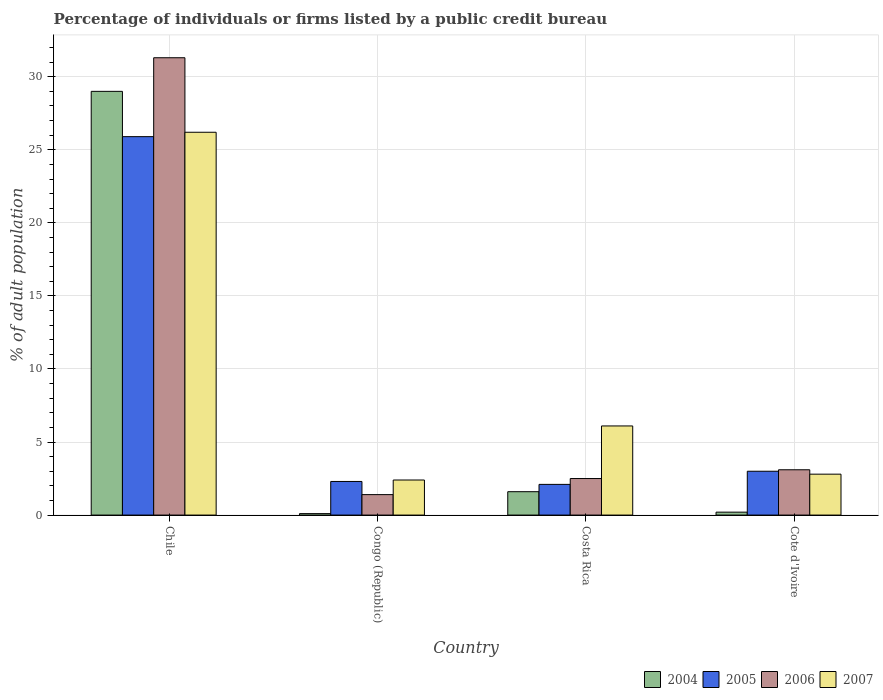How many groups of bars are there?
Make the answer very short. 4. Are the number of bars on each tick of the X-axis equal?
Ensure brevity in your answer.  Yes. How many bars are there on the 4th tick from the left?
Offer a terse response. 4. How many bars are there on the 1st tick from the right?
Your answer should be compact. 4. What is the label of the 4th group of bars from the left?
Give a very brief answer. Cote d'Ivoire. What is the percentage of population listed by a public credit bureau in 2005 in Chile?
Make the answer very short. 25.9. Across all countries, what is the maximum percentage of population listed by a public credit bureau in 2007?
Ensure brevity in your answer.  26.2. Across all countries, what is the minimum percentage of population listed by a public credit bureau in 2007?
Keep it short and to the point. 2.4. In which country was the percentage of population listed by a public credit bureau in 2006 maximum?
Provide a succinct answer. Chile. What is the total percentage of population listed by a public credit bureau in 2004 in the graph?
Ensure brevity in your answer.  30.9. What is the difference between the percentage of population listed by a public credit bureau in 2005 in Chile and that in Congo (Republic)?
Give a very brief answer. 23.6. What is the difference between the percentage of population listed by a public credit bureau in 2005 in Chile and the percentage of population listed by a public credit bureau in 2007 in Costa Rica?
Make the answer very short. 19.8. What is the average percentage of population listed by a public credit bureau in 2007 per country?
Your answer should be very brief. 9.37. What is the difference between the percentage of population listed by a public credit bureau of/in 2006 and percentage of population listed by a public credit bureau of/in 2004 in Costa Rica?
Make the answer very short. 0.9. In how many countries, is the percentage of population listed by a public credit bureau in 2007 greater than 31 %?
Give a very brief answer. 0. What is the ratio of the percentage of population listed by a public credit bureau in 2007 in Chile to that in Cote d'Ivoire?
Give a very brief answer. 9.36. Is the percentage of population listed by a public credit bureau in 2006 in Costa Rica less than that in Cote d'Ivoire?
Provide a short and direct response. Yes. What is the difference between the highest and the second highest percentage of population listed by a public credit bureau in 2007?
Offer a very short reply. 23.4. What is the difference between the highest and the lowest percentage of population listed by a public credit bureau in 2007?
Provide a short and direct response. 23.8. In how many countries, is the percentage of population listed by a public credit bureau in 2006 greater than the average percentage of population listed by a public credit bureau in 2006 taken over all countries?
Provide a succinct answer. 1. Is the sum of the percentage of population listed by a public credit bureau in 2004 in Chile and Cote d'Ivoire greater than the maximum percentage of population listed by a public credit bureau in 2006 across all countries?
Provide a short and direct response. No. Is it the case that in every country, the sum of the percentage of population listed by a public credit bureau in 2004 and percentage of population listed by a public credit bureau in 2005 is greater than the sum of percentage of population listed by a public credit bureau in 2007 and percentage of population listed by a public credit bureau in 2006?
Your answer should be compact. Yes. What does the 4th bar from the left in Costa Rica represents?
Ensure brevity in your answer.  2007. What does the 2nd bar from the right in Cote d'Ivoire represents?
Make the answer very short. 2006. Is it the case that in every country, the sum of the percentage of population listed by a public credit bureau in 2007 and percentage of population listed by a public credit bureau in 2005 is greater than the percentage of population listed by a public credit bureau in 2006?
Your answer should be very brief. Yes. Are all the bars in the graph horizontal?
Keep it short and to the point. No. Are the values on the major ticks of Y-axis written in scientific E-notation?
Provide a short and direct response. No. Does the graph contain grids?
Ensure brevity in your answer.  Yes. What is the title of the graph?
Make the answer very short. Percentage of individuals or firms listed by a public credit bureau. What is the label or title of the X-axis?
Offer a terse response. Country. What is the label or title of the Y-axis?
Ensure brevity in your answer.  % of adult population. What is the % of adult population of 2004 in Chile?
Your answer should be very brief. 29. What is the % of adult population in 2005 in Chile?
Make the answer very short. 25.9. What is the % of adult population in 2006 in Chile?
Your answer should be very brief. 31.3. What is the % of adult population in 2007 in Chile?
Your answer should be very brief. 26.2. What is the % of adult population in 2006 in Congo (Republic)?
Make the answer very short. 1.4. What is the % of adult population of 2005 in Costa Rica?
Offer a very short reply. 2.1. What is the % of adult population in 2006 in Costa Rica?
Offer a very short reply. 2.5. What is the % of adult population of 2004 in Cote d'Ivoire?
Your answer should be very brief. 0.2. What is the % of adult population of 2005 in Cote d'Ivoire?
Your answer should be compact. 3. Across all countries, what is the maximum % of adult population of 2005?
Ensure brevity in your answer.  25.9. Across all countries, what is the maximum % of adult population of 2006?
Your answer should be very brief. 31.3. Across all countries, what is the maximum % of adult population of 2007?
Your response must be concise. 26.2. Across all countries, what is the minimum % of adult population of 2005?
Offer a very short reply. 2.1. What is the total % of adult population of 2004 in the graph?
Ensure brevity in your answer.  30.9. What is the total % of adult population of 2005 in the graph?
Offer a terse response. 33.3. What is the total % of adult population in 2006 in the graph?
Your answer should be compact. 38.3. What is the total % of adult population of 2007 in the graph?
Your answer should be compact. 37.5. What is the difference between the % of adult population of 2004 in Chile and that in Congo (Republic)?
Keep it short and to the point. 28.9. What is the difference between the % of adult population in 2005 in Chile and that in Congo (Republic)?
Offer a terse response. 23.6. What is the difference between the % of adult population of 2006 in Chile and that in Congo (Republic)?
Make the answer very short. 29.9. What is the difference between the % of adult population in 2007 in Chile and that in Congo (Republic)?
Provide a short and direct response. 23.8. What is the difference between the % of adult population of 2004 in Chile and that in Costa Rica?
Provide a short and direct response. 27.4. What is the difference between the % of adult population of 2005 in Chile and that in Costa Rica?
Keep it short and to the point. 23.8. What is the difference between the % of adult population of 2006 in Chile and that in Costa Rica?
Keep it short and to the point. 28.8. What is the difference between the % of adult population in 2007 in Chile and that in Costa Rica?
Provide a short and direct response. 20.1. What is the difference between the % of adult population of 2004 in Chile and that in Cote d'Ivoire?
Provide a short and direct response. 28.8. What is the difference between the % of adult population in 2005 in Chile and that in Cote d'Ivoire?
Provide a succinct answer. 22.9. What is the difference between the % of adult population of 2006 in Chile and that in Cote d'Ivoire?
Your answer should be compact. 28.2. What is the difference between the % of adult population of 2007 in Chile and that in Cote d'Ivoire?
Provide a short and direct response. 23.4. What is the difference between the % of adult population in 2006 in Congo (Republic) and that in Costa Rica?
Your answer should be very brief. -1.1. What is the difference between the % of adult population in 2006 in Costa Rica and that in Cote d'Ivoire?
Give a very brief answer. -0.6. What is the difference between the % of adult population in 2004 in Chile and the % of adult population in 2005 in Congo (Republic)?
Keep it short and to the point. 26.7. What is the difference between the % of adult population in 2004 in Chile and the % of adult population in 2006 in Congo (Republic)?
Make the answer very short. 27.6. What is the difference between the % of adult population in 2004 in Chile and the % of adult population in 2007 in Congo (Republic)?
Give a very brief answer. 26.6. What is the difference between the % of adult population of 2005 in Chile and the % of adult population of 2007 in Congo (Republic)?
Your answer should be compact. 23.5. What is the difference between the % of adult population of 2006 in Chile and the % of adult population of 2007 in Congo (Republic)?
Provide a succinct answer. 28.9. What is the difference between the % of adult population in 2004 in Chile and the % of adult population in 2005 in Costa Rica?
Provide a short and direct response. 26.9. What is the difference between the % of adult population in 2004 in Chile and the % of adult population in 2007 in Costa Rica?
Provide a succinct answer. 22.9. What is the difference between the % of adult population in 2005 in Chile and the % of adult population in 2006 in Costa Rica?
Provide a succinct answer. 23.4. What is the difference between the % of adult population of 2005 in Chile and the % of adult population of 2007 in Costa Rica?
Your answer should be compact. 19.8. What is the difference between the % of adult population in 2006 in Chile and the % of adult population in 2007 in Costa Rica?
Make the answer very short. 25.2. What is the difference between the % of adult population of 2004 in Chile and the % of adult population of 2005 in Cote d'Ivoire?
Provide a short and direct response. 26. What is the difference between the % of adult population of 2004 in Chile and the % of adult population of 2006 in Cote d'Ivoire?
Provide a succinct answer. 25.9. What is the difference between the % of adult population in 2004 in Chile and the % of adult population in 2007 in Cote d'Ivoire?
Offer a terse response. 26.2. What is the difference between the % of adult population in 2005 in Chile and the % of adult population in 2006 in Cote d'Ivoire?
Give a very brief answer. 22.8. What is the difference between the % of adult population in 2005 in Chile and the % of adult population in 2007 in Cote d'Ivoire?
Offer a terse response. 23.1. What is the difference between the % of adult population in 2006 in Chile and the % of adult population in 2007 in Cote d'Ivoire?
Give a very brief answer. 28.5. What is the difference between the % of adult population in 2004 in Congo (Republic) and the % of adult population in 2007 in Costa Rica?
Offer a very short reply. -6. What is the difference between the % of adult population in 2006 in Congo (Republic) and the % of adult population in 2007 in Costa Rica?
Provide a short and direct response. -4.7. What is the difference between the % of adult population in 2004 in Congo (Republic) and the % of adult population in 2005 in Cote d'Ivoire?
Your answer should be compact. -2.9. What is the difference between the % of adult population in 2004 in Congo (Republic) and the % of adult population in 2006 in Cote d'Ivoire?
Give a very brief answer. -3. What is the difference between the % of adult population of 2004 in Congo (Republic) and the % of adult population of 2007 in Cote d'Ivoire?
Give a very brief answer. -2.7. What is the difference between the % of adult population of 2005 in Congo (Republic) and the % of adult population of 2006 in Cote d'Ivoire?
Ensure brevity in your answer.  -0.8. What is the difference between the % of adult population of 2004 in Costa Rica and the % of adult population of 2005 in Cote d'Ivoire?
Ensure brevity in your answer.  -1.4. What is the difference between the % of adult population of 2004 in Costa Rica and the % of adult population of 2006 in Cote d'Ivoire?
Keep it short and to the point. -1.5. What is the difference between the % of adult population of 2005 in Costa Rica and the % of adult population of 2007 in Cote d'Ivoire?
Ensure brevity in your answer.  -0.7. What is the average % of adult population in 2004 per country?
Give a very brief answer. 7.72. What is the average % of adult population in 2005 per country?
Offer a very short reply. 8.32. What is the average % of adult population in 2006 per country?
Make the answer very short. 9.57. What is the average % of adult population in 2007 per country?
Provide a succinct answer. 9.38. What is the difference between the % of adult population in 2004 and % of adult population in 2006 in Chile?
Give a very brief answer. -2.3. What is the difference between the % of adult population of 2004 and % of adult population of 2007 in Chile?
Make the answer very short. 2.8. What is the difference between the % of adult population of 2004 and % of adult population of 2007 in Congo (Republic)?
Make the answer very short. -2.3. What is the difference between the % of adult population of 2004 and % of adult population of 2005 in Costa Rica?
Keep it short and to the point. -0.5. What is the difference between the % of adult population in 2004 and % of adult population in 2007 in Costa Rica?
Offer a very short reply. -4.5. What is the difference between the % of adult population in 2005 and % of adult population in 2006 in Costa Rica?
Ensure brevity in your answer.  -0.4. What is the difference between the % of adult population of 2004 and % of adult population of 2006 in Cote d'Ivoire?
Provide a succinct answer. -2.9. What is the difference between the % of adult population of 2004 and % of adult population of 2007 in Cote d'Ivoire?
Make the answer very short. -2.6. What is the difference between the % of adult population of 2005 and % of adult population of 2006 in Cote d'Ivoire?
Your answer should be very brief. -0.1. What is the difference between the % of adult population in 2006 and % of adult population in 2007 in Cote d'Ivoire?
Provide a short and direct response. 0.3. What is the ratio of the % of adult population in 2004 in Chile to that in Congo (Republic)?
Make the answer very short. 290. What is the ratio of the % of adult population in 2005 in Chile to that in Congo (Republic)?
Your answer should be compact. 11.26. What is the ratio of the % of adult population of 2006 in Chile to that in Congo (Republic)?
Make the answer very short. 22.36. What is the ratio of the % of adult population in 2007 in Chile to that in Congo (Republic)?
Ensure brevity in your answer.  10.92. What is the ratio of the % of adult population in 2004 in Chile to that in Costa Rica?
Ensure brevity in your answer.  18.12. What is the ratio of the % of adult population in 2005 in Chile to that in Costa Rica?
Give a very brief answer. 12.33. What is the ratio of the % of adult population in 2006 in Chile to that in Costa Rica?
Make the answer very short. 12.52. What is the ratio of the % of adult population in 2007 in Chile to that in Costa Rica?
Keep it short and to the point. 4.3. What is the ratio of the % of adult population in 2004 in Chile to that in Cote d'Ivoire?
Your answer should be compact. 145. What is the ratio of the % of adult population of 2005 in Chile to that in Cote d'Ivoire?
Make the answer very short. 8.63. What is the ratio of the % of adult population in 2006 in Chile to that in Cote d'Ivoire?
Your response must be concise. 10.1. What is the ratio of the % of adult population in 2007 in Chile to that in Cote d'Ivoire?
Offer a terse response. 9.36. What is the ratio of the % of adult population of 2004 in Congo (Republic) to that in Costa Rica?
Give a very brief answer. 0.06. What is the ratio of the % of adult population of 2005 in Congo (Republic) to that in Costa Rica?
Keep it short and to the point. 1.1. What is the ratio of the % of adult population of 2006 in Congo (Republic) to that in Costa Rica?
Offer a terse response. 0.56. What is the ratio of the % of adult population of 2007 in Congo (Republic) to that in Costa Rica?
Offer a very short reply. 0.39. What is the ratio of the % of adult population of 2005 in Congo (Republic) to that in Cote d'Ivoire?
Your answer should be compact. 0.77. What is the ratio of the % of adult population of 2006 in Congo (Republic) to that in Cote d'Ivoire?
Make the answer very short. 0.45. What is the ratio of the % of adult population in 2007 in Congo (Republic) to that in Cote d'Ivoire?
Your answer should be compact. 0.86. What is the ratio of the % of adult population of 2004 in Costa Rica to that in Cote d'Ivoire?
Ensure brevity in your answer.  8. What is the ratio of the % of adult population of 2005 in Costa Rica to that in Cote d'Ivoire?
Keep it short and to the point. 0.7. What is the ratio of the % of adult population in 2006 in Costa Rica to that in Cote d'Ivoire?
Keep it short and to the point. 0.81. What is the ratio of the % of adult population of 2007 in Costa Rica to that in Cote d'Ivoire?
Give a very brief answer. 2.18. What is the difference between the highest and the second highest % of adult population in 2004?
Provide a succinct answer. 27.4. What is the difference between the highest and the second highest % of adult population in 2005?
Give a very brief answer. 22.9. What is the difference between the highest and the second highest % of adult population of 2006?
Make the answer very short. 28.2. What is the difference between the highest and the second highest % of adult population of 2007?
Keep it short and to the point. 20.1. What is the difference between the highest and the lowest % of adult population in 2004?
Offer a very short reply. 28.9. What is the difference between the highest and the lowest % of adult population of 2005?
Offer a very short reply. 23.8. What is the difference between the highest and the lowest % of adult population in 2006?
Make the answer very short. 29.9. What is the difference between the highest and the lowest % of adult population in 2007?
Your answer should be compact. 23.8. 